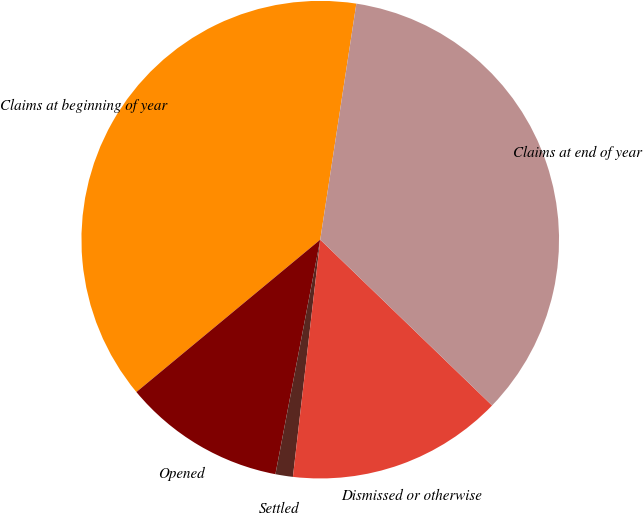Convert chart. <chart><loc_0><loc_0><loc_500><loc_500><pie_chart><fcel>Claims at beginning of year<fcel>Opened<fcel>Settled<fcel>Dismissed or otherwise<fcel>Claims at end of year<nl><fcel>38.43%<fcel>10.98%<fcel>1.18%<fcel>14.61%<fcel>34.8%<nl></chart> 